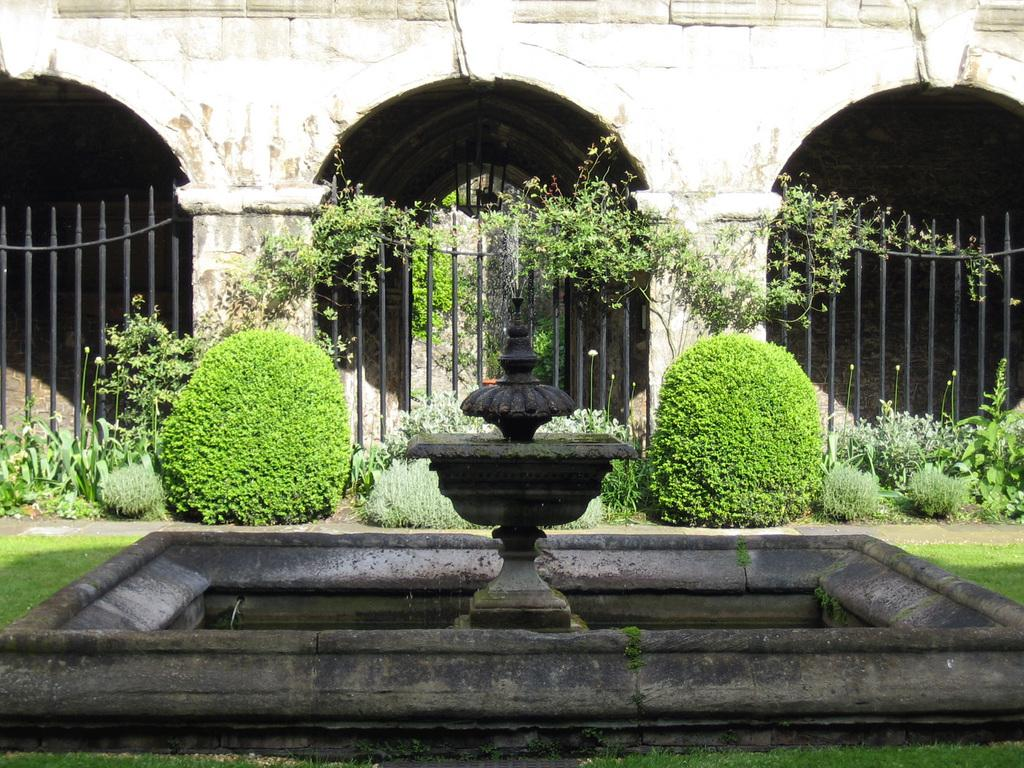What is the main feature in the center of the image? There is a fountain in the center of the image. What can be seen in the background of the image? There is a fence, plants, and a building in the background of the image. What type of vegetation is present in the image? There are plants in the background of the image. What is the ground surface like in the image? There is grass at the bottom of the image. What type of instrument is being played by the person in the image? There is no person or instrument present in the image; it features a fountain, fence, plants, and a building in the background. What kind of cake is being served at the event in the image? There is no event or cake present in the image; it focuses on the fountain and the surrounding environment. 